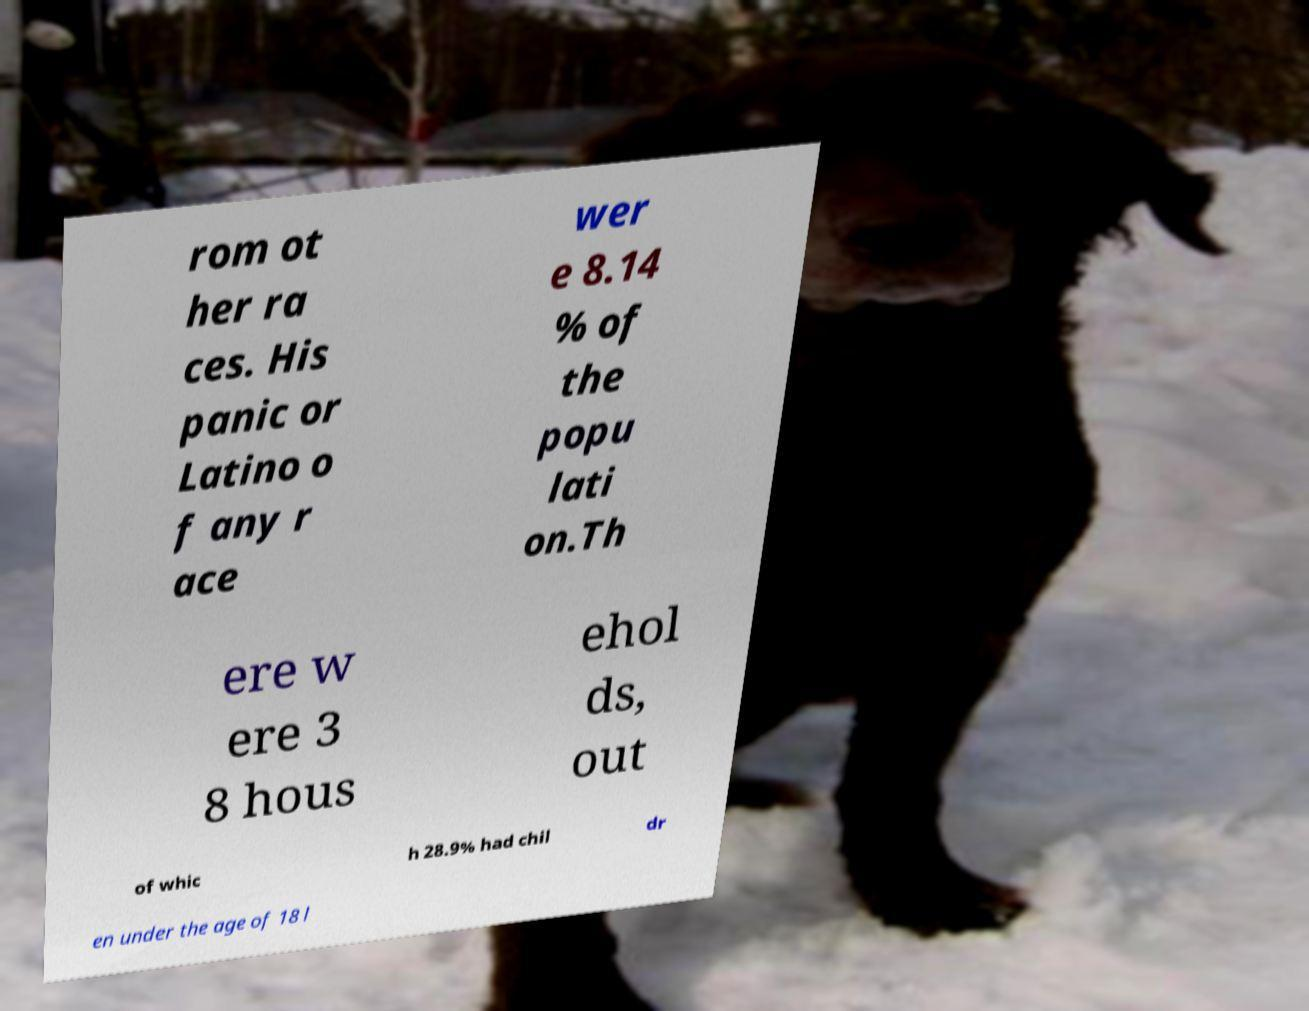Could you extract and type out the text from this image? rom ot her ra ces. His panic or Latino o f any r ace wer e 8.14 % of the popu lati on.Th ere w ere 3 8 hous ehol ds, out of whic h 28.9% had chil dr en under the age of 18 l 